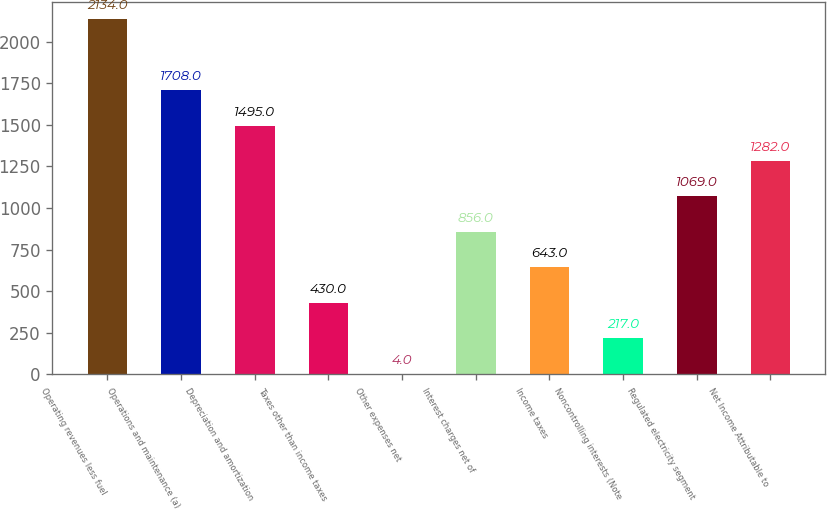Convert chart. <chart><loc_0><loc_0><loc_500><loc_500><bar_chart><fcel>Operating revenues less fuel<fcel>Operations and maintenance (a)<fcel>Depreciation and amortization<fcel>Taxes other than income taxes<fcel>Other expenses net<fcel>Interest charges net of<fcel>Income taxes<fcel>Noncontrolling interests (Note<fcel>Regulated electricity segment<fcel>Net Income Attributable to<nl><fcel>2134<fcel>1708<fcel>1495<fcel>430<fcel>4<fcel>856<fcel>643<fcel>217<fcel>1069<fcel>1282<nl></chart> 